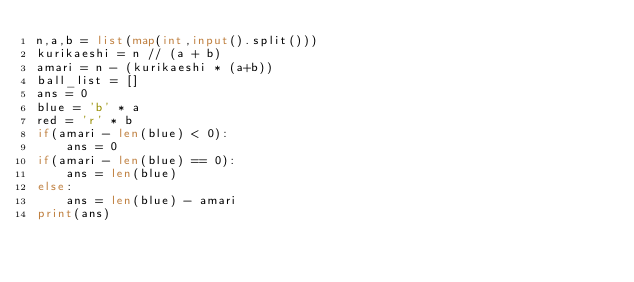<code> <loc_0><loc_0><loc_500><loc_500><_Python_>n,a,b = list(map(int,input().split()))
kurikaeshi = n // (a + b)
amari = n - (kurikaeshi * (a+b))
ball_list = []
ans = 0
blue = 'b' * a
red = 'r' * b
if(amari - len(blue) < 0):
    ans = 0
if(amari - len(blue) == 0):
    ans = len(blue)
else:
    ans = len(blue) - amari
print(ans)</code> 